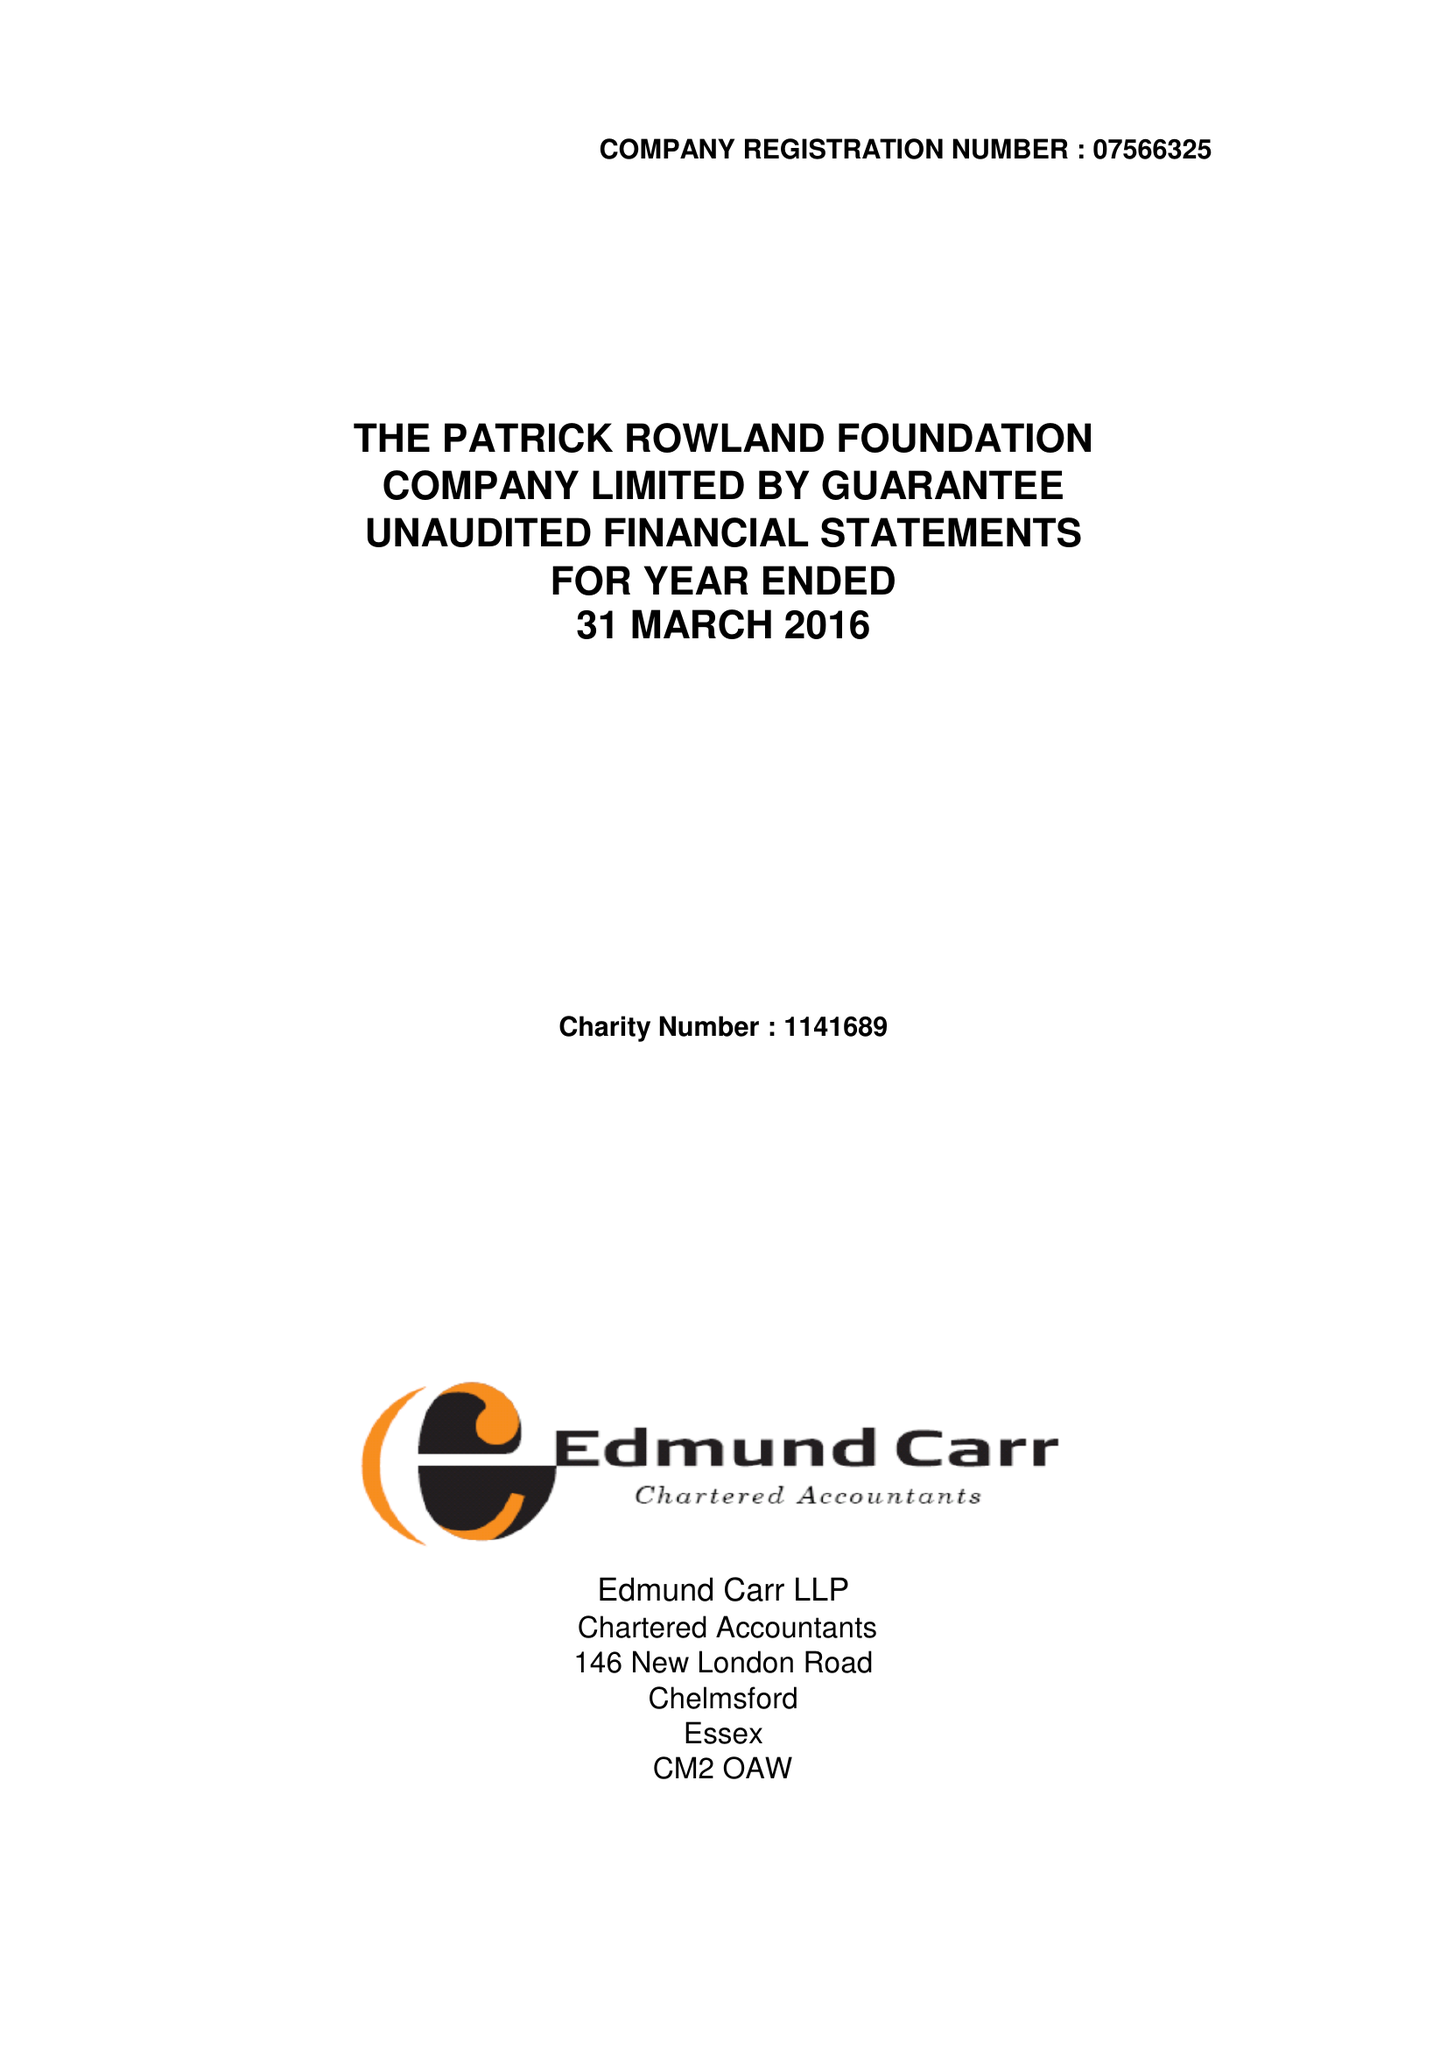What is the value for the address__post_town?
Answer the question using a single word or phrase. CHELMSFORD 